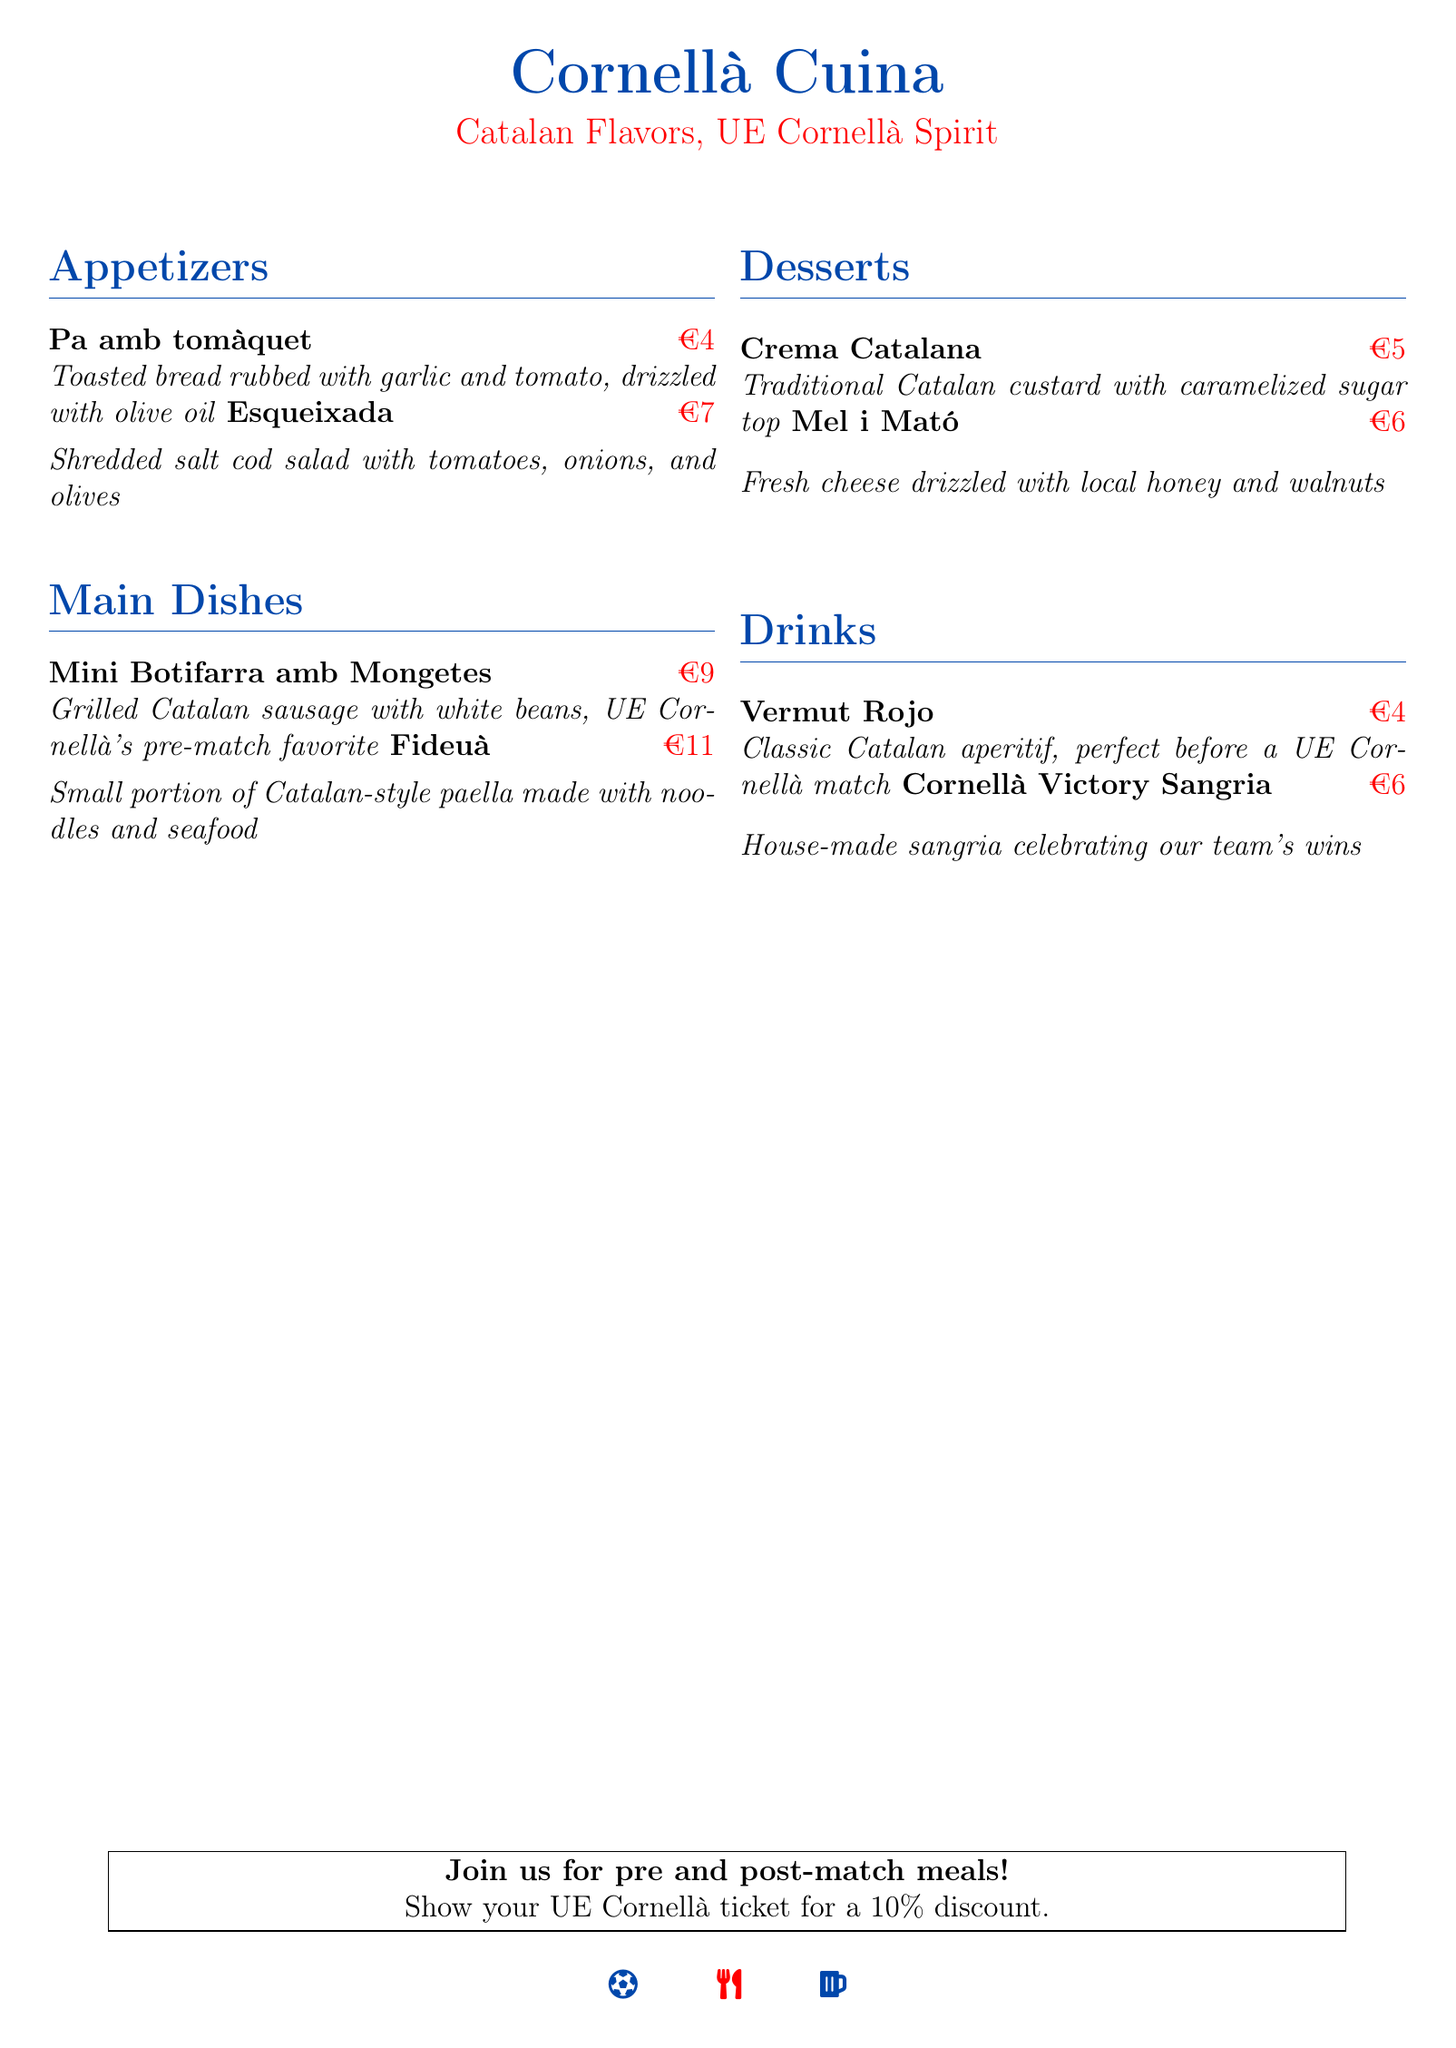What is the name of the restaurant? The name of the restaurant is stated clearly at the beginning of the document as "Cornellà Cuina."
Answer: Cornellà Cuina What is the price of Fideuà? The price of Fideuà can be found next to its description under the Main Dishes section.
Answer: €11 What type of drink is Vermut Rojo? The document specifies that Vermut Rojo is a classic Catalan aperitif.
Answer: Classic Catalan aperitif Which dessert has a caramelized sugar top? The dessert that has a caramelized sugar top is described in the Desserts section.
Answer: Crema Catalana What dish features white beans? The dish that features white beans is listed under Main Dishes.
Answer: Mini Botifarra amb Mongetes What discount is offered for showing a UE Cornellà ticket? The document states the specific discount offered for ticket holders.
Answer: 10% What is the price of Mel i Mató? The price for Mel i Mató is indicated under the Desserts section.
Answer: €6 What is the signature drink celebrating the team's wins? The drink celebrating the team’s wins is mentioned under Drinks.
Answer: Cornellà Victory Sangria 